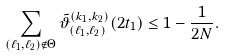<formula> <loc_0><loc_0><loc_500><loc_500>\sum _ { ( \ell _ { 1 } , \ell _ { 2 } ) \notin \Theta } \tilde { \vartheta } _ { ( \ell _ { 1 } , \ell _ { 2 } ) } ^ { ( k _ { 1 } , k _ { 2 } ) } ( 2 t _ { 1 } ) \leq 1 - \frac { 1 } { 2 N } .</formula> 